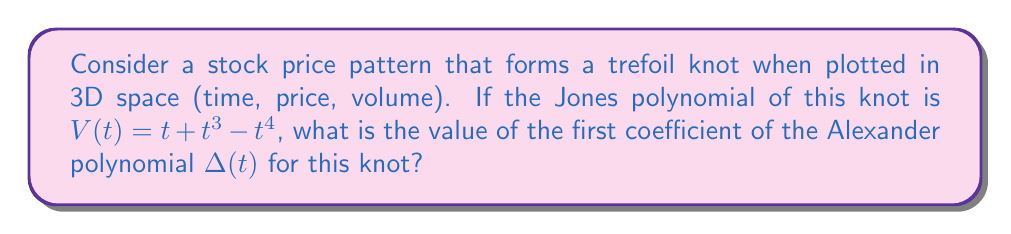Can you answer this question? To solve this problem, we'll follow these steps:

1) First, recall that for any knot, the Jones polynomial $V(t)$ and the Alexander polynomial $\Delta(t)$ are related by the following formula:

   $$\Delta(t) = V(t^{1/2} - t^{-1/2})$$

2) We're given that $V(t) = t + t^3 - t^4$. Let's substitute $t^{1/2} - t^{-1/2}$ for $t$ in this expression:

   $$\Delta(t) = (t^{1/2} - t^{-1/2}) + (t^{1/2} - t^{-1/2})^3 - (t^{1/2} - t^{-1/2})^4$$

3) Expand the cubic term:
   $$(t^{1/2} - t^{-1/2})^3 = t^{3/2} - 3t^{1/2} + 3t^{-1/2} - t^{-3/2}$$

4) Expand the fourth power term:
   $$(t^{1/2} - t^{-1/2})^4 = t^2 - 4t + 6 - 4t^{-1} + t^{-2}$$

5) Substituting these back into the equation:

   $$\Delta(t) = (t^{1/2} - t^{-1/2}) + (t^{3/2} - 3t^{1/2} + 3t^{-1/2} - t^{-3/2}) - (t^2 - 4t + 6 - 4t^{-1} + t^{-2})$$

6) Simplify and collect like terms:

   $$\Delta(t) = -t^2 + 4t + t^{3/2} - 2t^{1/2} + 2t^{-1/2} - t^{-3/2} - 6 + 4t^{-1} - t^{-2}$$

7) The Alexander polynomial is typically normalized so that the lowest degree term has a positive coefficient. In this case, we can multiply everything by $-t^2$:

   $$\Delta(t) = 1 - 4t - t^{5/2} + 2t^{3/2} - 2t^{3/2} + t^{1/2} + 6t^2 - 4t^3 + t^4$$

8) The first coefficient of the Alexander polynomial is the constant term, which in this case is 1.
Answer: 1 